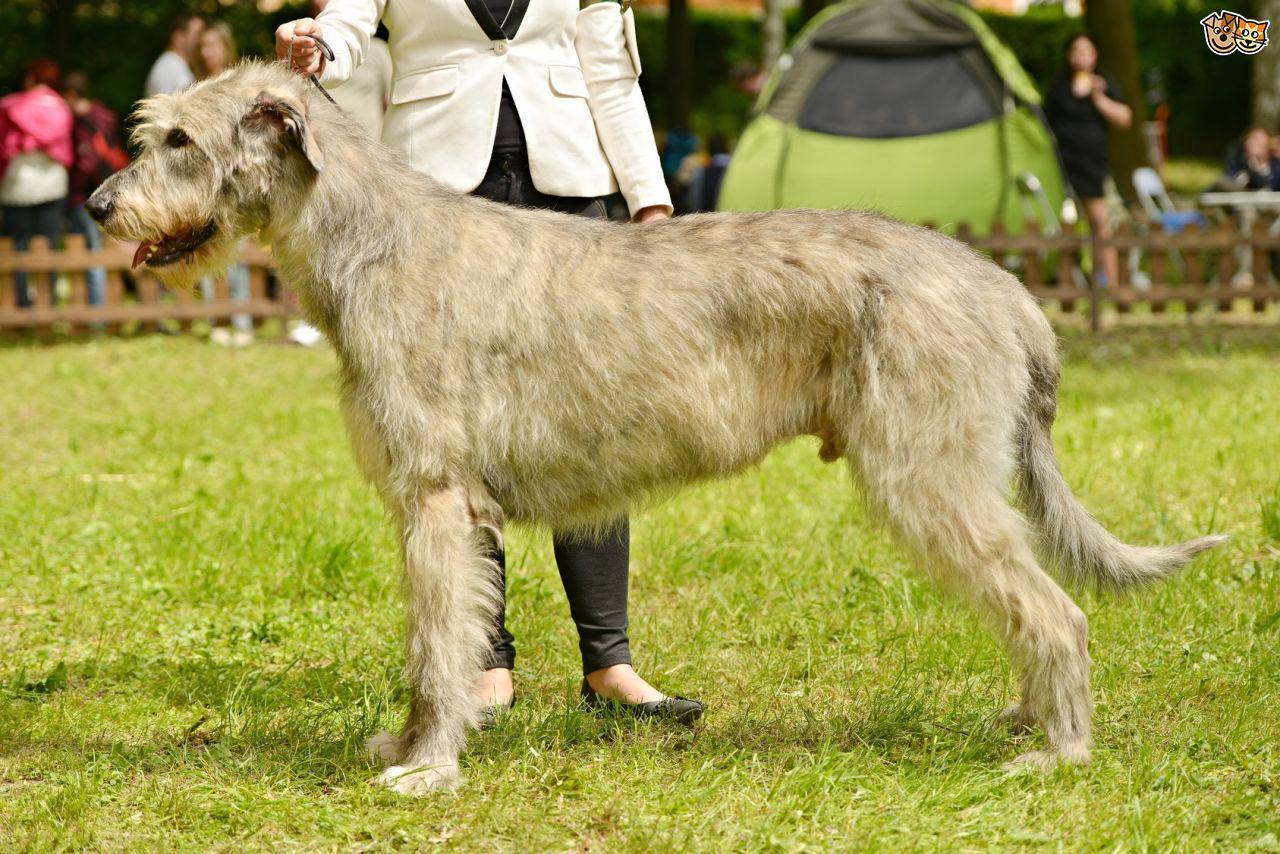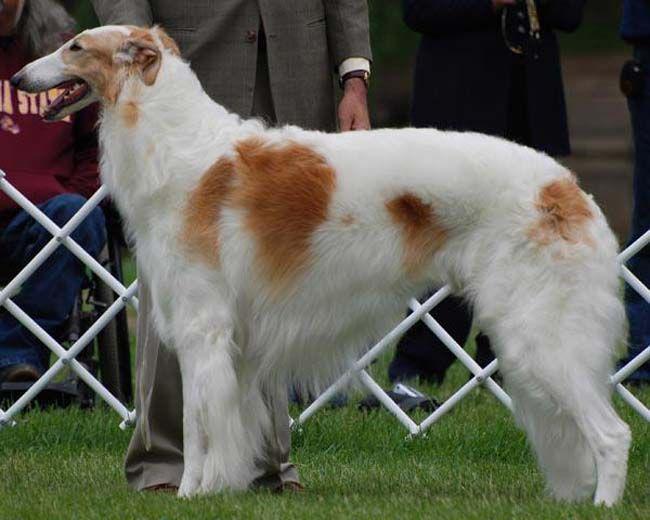The first image is the image on the left, the second image is the image on the right. Considering the images on both sides, is "All hounds shown are trotting on a green surface, and one of the dogs is trotting leftward alongside a person on green carpet." valid? Answer yes or no. No. 